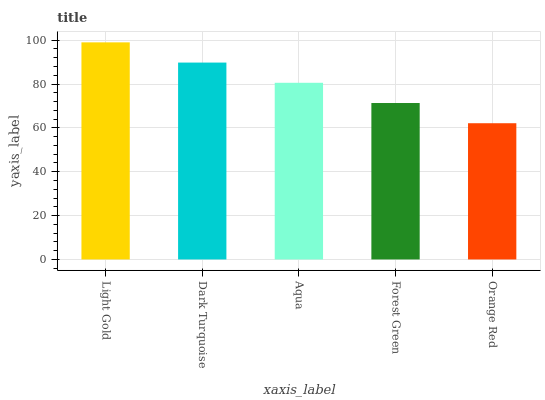Is Orange Red the minimum?
Answer yes or no. Yes. Is Light Gold the maximum?
Answer yes or no. Yes. Is Dark Turquoise the minimum?
Answer yes or no. No. Is Dark Turquoise the maximum?
Answer yes or no. No. Is Light Gold greater than Dark Turquoise?
Answer yes or no. Yes. Is Dark Turquoise less than Light Gold?
Answer yes or no. Yes. Is Dark Turquoise greater than Light Gold?
Answer yes or no. No. Is Light Gold less than Dark Turquoise?
Answer yes or no. No. Is Aqua the high median?
Answer yes or no. Yes. Is Aqua the low median?
Answer yes or no. Yes. Is Light Gold the high median?
Answer yes or no. No. Is Forest Green the low median?
Answer yes or no. No. 